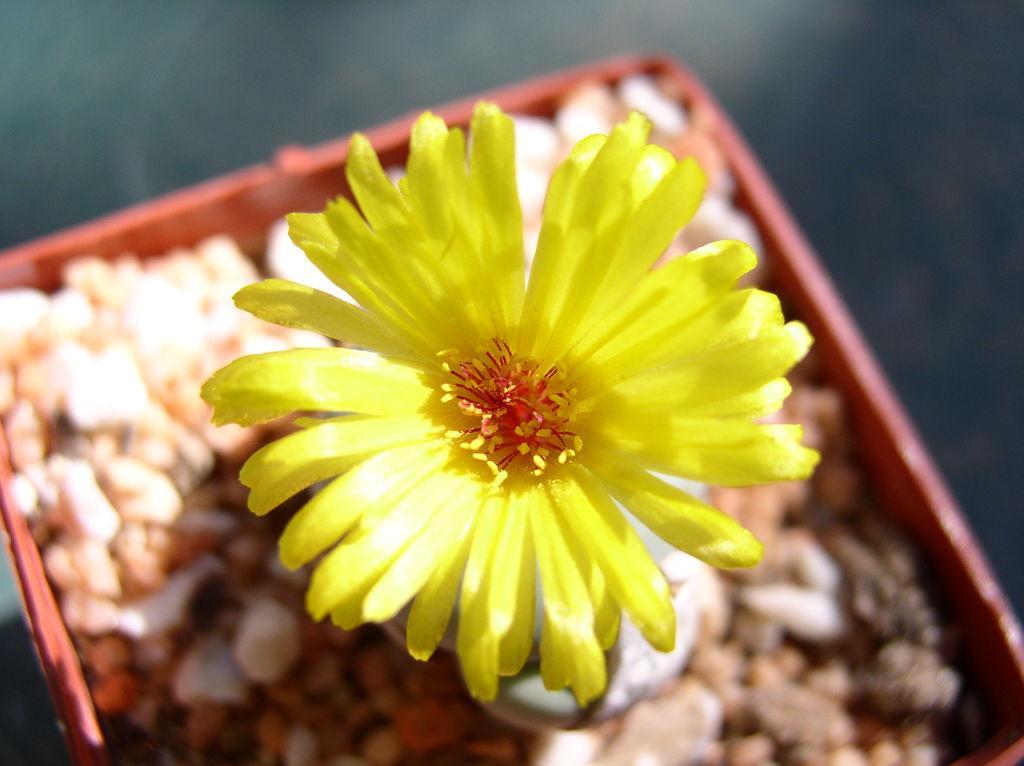Describe this image in one or two sentences. In the image I can see a flower which is in the basket in which there are some stones and rocks. 